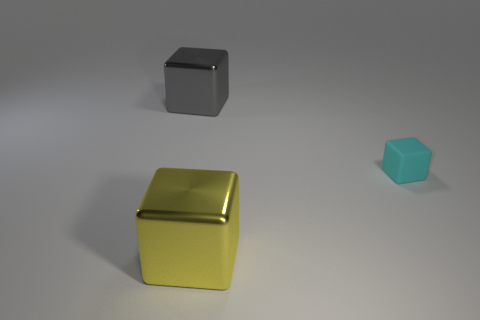Can you tell me the approximate position of the smallest cube? The smallest cube is positioned to the far right of the image, at a significant distance from the other two cubes. What can the different sizes of the cubes tell us about their placement? The varying sizes of the cubes might suggest a play on perspective or space, where objects placed further away could be perceived as smaller, contributing to an illusion of depth in the image. 